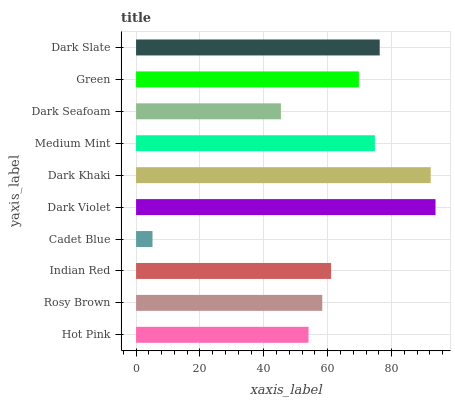Is Cadet Blue the minimum?
Answer yes or no. Yes. Is Dark Violet the maximum?
Answer yes or no. Yes. Is Rosy Brown the minimum?
Answer yes or no. No. Is Rosy Brown the maximum?
Answer yes or no. No. Is Rosy Brown greater than Hot Pink?
Answer yes or no. Yes. Is Hot Pink less than Rosy Brown?
Answer yes or no. Yes. Is Hot Pink greater than Rosy Brown?
Answer yes or no. No. Is Rosy Brown less than Hot Pink?
Answer yes or no. No. Is Green the high median?
Answer yes or no. Yes. Is Indian Red the low median?
Answer yes or no. Yes. Is Dark Seafoam the high median?
Answer yes or no. No. Is Dark Violet the low median?
Answer yes or no. No. 